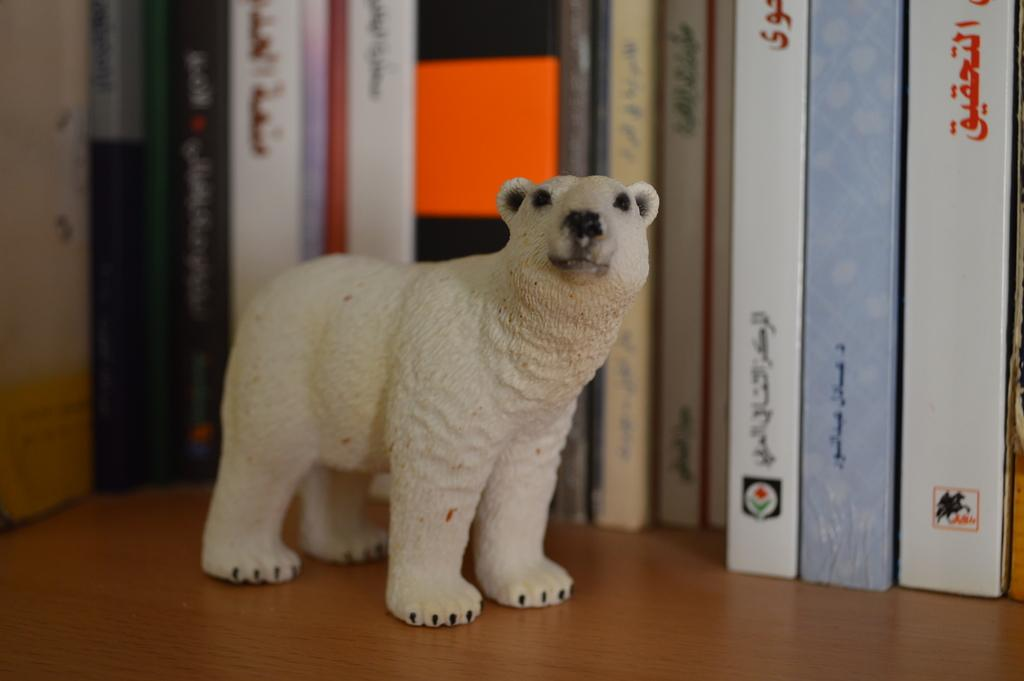What is the main subject in the center of the image? There is a depiction of an animal in the center of the image. What can be seen in the background of the image? There are books in the background of the image. What is located at the bottom of the image? There is a table at the bottom of the image. What type of plant is being cooked in the image? There is no plant being cooked in the image; it only features a depiction of an animal, books, and a table. 